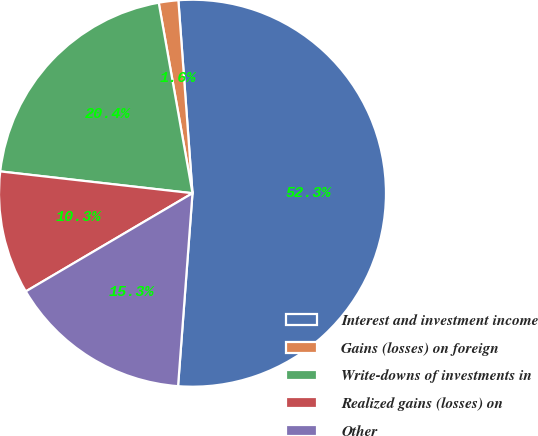Convert chart. <chart><loc_0><loc_0><loc_500><loc_500><pie_chart><fcel>Interest and investment income<fcel>Gains (losses) on foreign<fcel>Write-downs of investments in<fcel>Realized gains (losses) on<fcel>Other<nl><fcel>52.35%<fcel>1.63%<fcel>20.41%<fcel>10.27%<fcel>15.34%<nl></chart> 